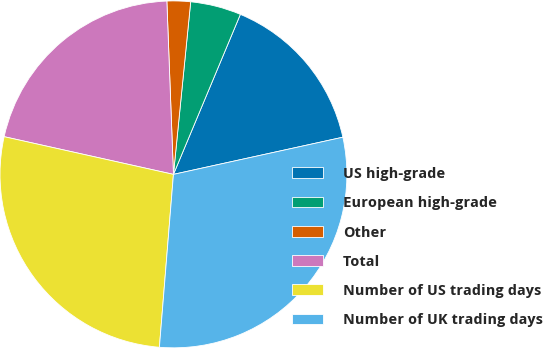Convert chart. <chart><loc_0><loc_0><loc_500><loc_500><pie_chart><fcel>US high-grade<fcel>European high-grade<fcel>Other<fcel>Total<fcel>Number of US trading days<fcel>Number of UK trading days<nl><fcel>15.26%<fcel>4.72%<fcel>2.19%<fcel>20.91%<fcel>27.2%<fcel>29.73%<nl></chart> 